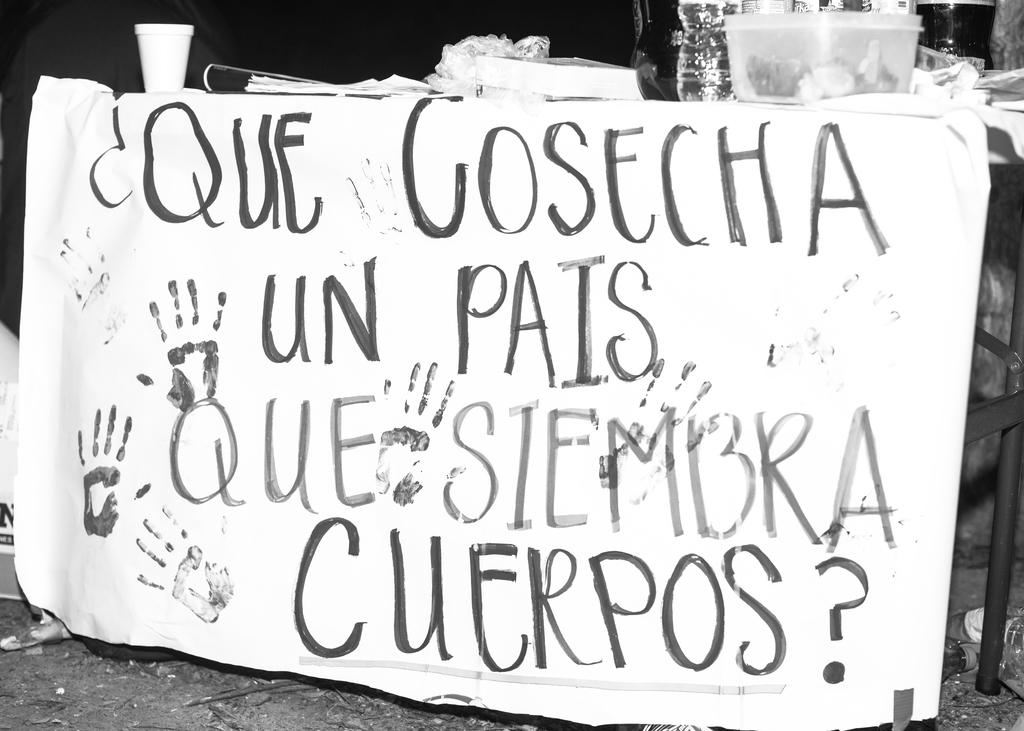What is the color scheme of the image? The image is black and white. What can be seen hanging in the image? There is a banner in the image. What is written on the banner? There is text written on the banner. How is the banner attached in the image? The banner is attached to a table. What is present on the table in the image? There is a table in the image with a basket, glasses, a cover, a book, and papers on it. What type of copper material is used to make the locket on the table in the image? There is no locket present in the image, and therefore no copper material can be observed. What type of building is visible in the background of the image? There is no building visible in the image; it is a black and white scene with a table, banner, and various objects on the table. 